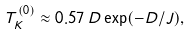<formula> <loc_0><loc_0><loc_500><loc_500>T _ { K } ^ { ( 0 ) } \approx 0 . 5 7 \, D \exp ( - D / J ) ,</formula> 